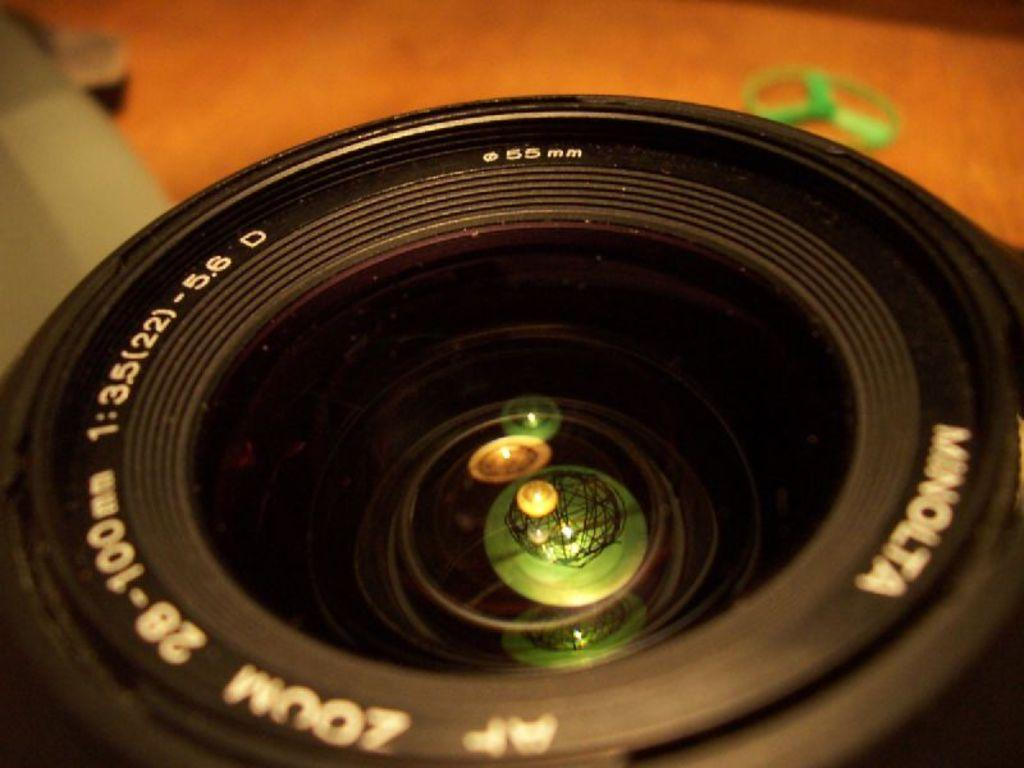What is the main subject of the image? The main subject of the image is a lens. Are there any words or letters on the lens? Yes, there is text on the lens. What can be seen at the top of the image? There is an object on a surface at the top of the image. Where is the doll playing in the image? There is no doll present in the image, so it cannot be determined where a doll might be playing. 